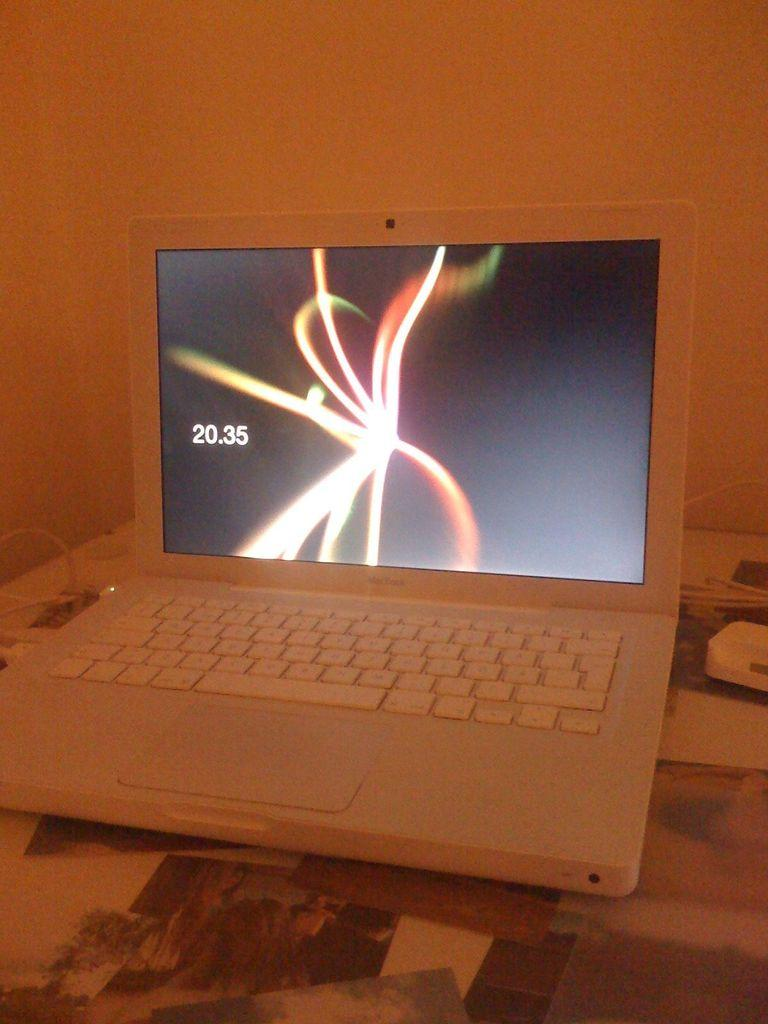<image>
Provide a brief description of the given image. A MacBook laptop is open, with the screen displaying the time of 20:35. 